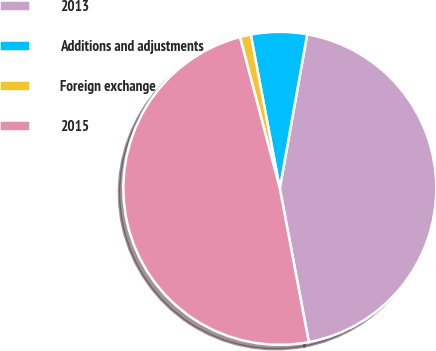Convert chart. <chart><loc_0><loc_0><loc_500><loc_500><pie_chart><fcel>2013<fcel>Additions and adjustments<fcel>Foreign exchange<fcel>2015<nl><fcel>44.23%<fcel>5.77%<fcel>1.13%<fcel>48.87%<nl></chart> 